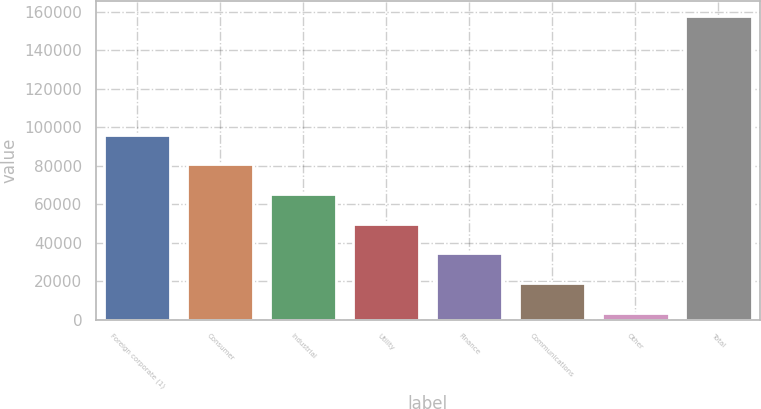<chart> <loc_0><loc_0><loc_500><loc_500><bar_chart><fcel>Foreign corporate (1)<fcel>Consumer<fcel>Industrial<fcel>Utility<fcel>Finance<fcel>Communications<fcel>Other<fcel>Total<nl><fcel>96229.6<fcel>80789<fcel>65348.4<fcel>49907.8<fcel>34467.2<fcel>19026.6<fcel>3586<fcel>157992<nl></chart> 